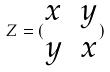Convert formula to latex. <formula><loc_0><loc_0><loc_500><loc_500>Z = ( \begin{matrix} x & y \\ y & x \end{matrix} )</formula> 